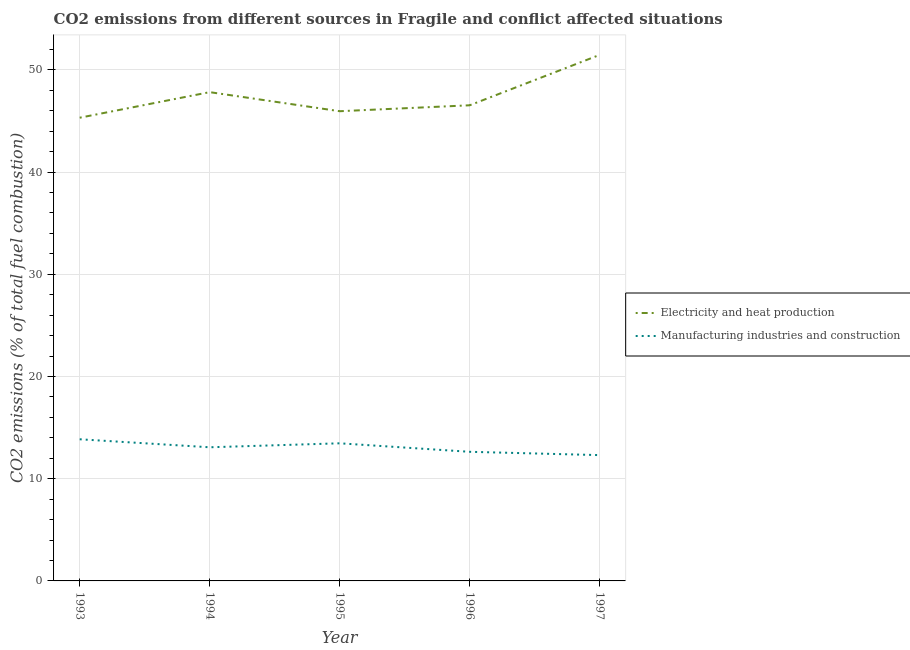Is the number of lines equal to the number of legend labels?
Ensure brevity in your answer.  Yes. What is the co2 emissions due to electricity and heat production in 1993?
Provide a short and direct response. 45.32. Across all years, what is the maximum co2 emissions due to electricity and heat production?
Your response must be concise. 51.46. Across all years, what is the minimum co2 emissions due to manufacturing industries?
Make the answer very short. 12.31. In which year was the co2 emissions due to electricity and heat production maximum?
Keep it short and to the point. 1997. What is the total co2 emissions due to manufacturing industries in the graph?
Your answer should be compact. 65.34. What is the difference between the co2 emissions due to electricity and heat production in 1993 and that in 1994?
Offer a terse response. -2.5. What is the difference between the co2 emissions due to electricity and heat production in 1993 and the co2 emissions due to manufacturing industries in 1994?
Ensure brevity in your answer.  32.24. What is the average co2 emissions due to manufacturing industries per year?
Make the answer very short. 13.07. In the year 1997, what is the difference between the co2 emissions due to electricity and heat production and co2 emissions due to manufacturing industries?
Ensure brevity in your answer.  39.16. What is the ratio of the co2 emissions due to electricity and heat production in 1993 to that in 1996?
Give a very brief answer. 0.97. Is the co2 emissions due to manufacturing industries in 1993 less than that in 1994?
Offer a very short reply. No. What is the difference between the highest and the second highest co2 emissions due to manufacturing industries?
Your answer should be compact. 0.39. What is the difference between the highest and the lowest co2 emissions due to electricity and heat production?
Give a very brief answer. 6.15. Is the co2 emissions due to electricity and heat production strictly less than the co2 emissions due to manufacturing industries over the years?
Make the answer very short. No. How many lines are there?
Keep it short and to the point. 2. How many years are there in the graph?
Keep it short and to the point. 5. What is the difference between two consecutive major ticks on the Y-axis?
Keep it short and to the point. 10. Does the graph contain grids?
Provide a succinct answer. Yes. How many legend labels are there?
Your answer should be compact. 2. How are the legend labels stacked?
Ensure brevity in your answer.  Vertical. What is the title of the graph?
Ensure brevity in your answer.  CO2 emissions from different sources in Fragile and conflict affected situations. What is the label or title of the X-axis?
Your response must be concise. Year. What is the label or title of the Y-axis?
Ensure brevity in your answer.  CO2 emissions (% of total fuel combustion). What is the CO2 emissions (% of total fuel combustion) of Electricity and heat production in 1993?
Offer a terse response. 45.32. What is the CO2 emissions (% of total fuel combustion) in Manufacturing industries and construction in 1993?
Offer a terse response. 13.86. What is the CO2 emissions (% of total fuel combustion) of Electricity and heat production in 1994?
Ensure brevity in your answer.  47.82. What is the CO2 emissions (% of total fuel combustion) in Manufacturing industries and construction in 1994?
Provide a succinct answer. 13.07. What is the CO2 emissions (% of total fuel combustion) in Electricity and heat production in 1995?
Provide a short and direct response. 45.95. What is the CO2 emissions (% of total fuel combustion) of Manufacturing industries and construction in 1995?
Keep it short and to the point. 13.46. What is the CO2 emissions (% of total fuel combustion) in Electricity and heat production in 1996?
Your response must be concise. 46.53. What is the CO2 emissions (% of total fuel combustion) of Manufacturing industries and construction in 1996?
Keep it short and to the point. 12.63. What is the CO2 emissions (% of total fuel combustion) of Electricity and heat production in 1997?
Ensure brevity in your answer.  51.46. What is the CO2 emissions (% of total fuel combustion) in Manufacturing industries and construction in 1997?
Make the answer very short. 12.31. Across all years, what is the maximum CO2 emissions (% of total fuel combustion) in Electricity and heat production?
Your answer should be very brief. 51.46. Across all years, what is the maximum CO2 emissions (% of total fuel combustion) of Manufacturing industries and construction?
Ensure brevity in your answer.  13.86. Across all years, what is the minimum CO2 emissions (% of total fuel combustion) of Electricity and heat production?
Your answer should be very brief. 45.32. Across all years, what is the minimum CO2 emissions (% of total fuel combustion) in Manufacturing industries and construction?
Offer a terse response. 12.31. What is the total CO2 emissions (% of total fuel combustion) of Electricity and heat production in the graph?
Give a very brief answer. 237.08. What is the total CO2 emissions (% of total fuel combustion) of Manufacturing industries and construction in the graph?
Offer a very short reply. 65.34. What is the difference between the CO2 emissions (% of total fuel combustion) of Electricity and heat production in 1993 and that in 1994?
Your answer should be very brief. -2.5. What is the difference between the CO2 emissions (% of total fuel combustion) of Manufacturing industries and construction in 1993 and that in 1994?
Provide a short and direct response. 0.78. What is the difference between the CO2 emissions (% of total fuel combustion) in Electricity and heat production in 1993 and that in 1995?
Your answer should be very brief. -0.64. What is the difference between the CO2 emissions (% of total fuel combustion) in Manufacturing industries and construction in 1993 and that in 1995?
Your response must be concise. 0.39. What is the difference between the CO2 emissions (% of total fuel combustion) of Electricity and heat production in 1993 and that in 1996?
Give a very brief answer. -1.22. What is the difference between the CO2 emissions (% of total fuel combustion) in Manufacturing industries and construction in 1993 and that in 1996?
Provide a short and direct response. 1.23. What is the difference between the CO2 emissions (% of total fuel combustion) in Electricity and heat production in 1993 and that in 1997?
Provide a succinct answer. -6.15. What is the difference between the CO2 emissions (% of total fuel combustion) in Manufacturing industries and construction in 1993 and that in 1997?
Your answer should be very brief. 1.55. What is the difference between the CO2 emissions (% of total fuel combustion) of Electricity and heat production in 1994 and that in 1995?
Make the answer very short. 1.87. What is the difference between the CO2 emissions (% of total fuel combustion) in Manufacturing industries and construction in 1994 and that in 1995?
Your answer should be very brief. -0.39. What is the difference between the CO2 emissions (% of total fuel combustion) of Electricity and heat production in 1994 and that in 1996?
Provide a succinct answer. 1.29. What is the difference between the CO2 emissions (% of total fuel combustion) of Manufacturing industries and construction in 1994 and that in 1996?
Provide a succinct answer. 0.44. What is the difference between the CO2 emissions (% of total fuel combustion) of Electricity and heat production in 1994 and that in 1997?
Keep it short and to the point. -3.65. What is the difference between the CO2 emissions (% of total fuel combustion) of Manufacturing industries and construction in 1994 and that in 1997?
Your response must be concise. 0.77. What is the difference between the CO2 emissions (% of total fuel combustion) of Electricity and heat production in 1995 and that in 1996?
Offer a terse response. -0.58. What is the difference between the CO2 emissions (% of total fuel combustion) in Manufacturing industries and construction in 1995 and that in 1996?
Offer a terse response. 0.83. What is the difference between the CO2 emissions (% of total fuel combustion) in Electricity and heat production in 1995 and that in 1997?
Offer a very short reply. -5.51. What is the difference between the CO2 emissions (% of total fuel combustion) of Manufacturing industries and construction in 1995 and that in 1997?
Ensure brevity in your answer.  1.16. What is the difference between the CO2 emissions (% of total fuel combustion) of Electricity and heat production in 1996 and that in 1997?
Offer a terse response. -4.93. What is the difference between the CO2 emissions (% of total fuel combustion) in Manufacturing industries and construction in 1996 and that in 1997?
Offer a very short reply. 0.32. What is the difference between the CO2 emissions (% of total fuel combustion) in Electricity and heat production in 1993 and the CO2 emissions (% of total fuel combustion) in Manufacturing industries and construction in 1994?
Give a very brief answer. 32.24. What is the difference between the CO2 emissions (% of total fuel combustion) of Electricity and heat production in 1993 and the CO2 emissions (% of total fuel combustion) of Manufacturing industries and construction in 1995?
Your answer should be very brief. 31.85. What is the difference between the CO2 emissions (% of total fuel combustion) in Electricity and heat production in 1993 and the CO2 emissions (% of total fuel combustion) in Manufacturing industries and construction in 1996?
Your answer should be very brief. 32.68. What is the difference between the CO2 emissions (% of total fuel combustion) of Electricity and heat production in 1993 and the CO2 emissions (% of total fuel combustion) of Manufacturing industries and construction in 1997?
Provide a short and direct response. 33.01. What is the difference between the CO2 emissions (% of total fuel combustion) of Electricity and heat production in 1994 and the CO2 emissions (% of total fuel combustion) of Manufacturing industries and construction in 1995?
Keep it short and to the point. 34.35. What is the difference between the CO2 emissions (% of total fuel combustion) of Electricity and heat production in 1994 and the CO2 emissions (% of total fuel combustion) of Manufacturing industries and construction in 1996?
Your answer should be very brief. 35.19. What is the difference between the CO2 emissions (% of total fuel combustion) of Electricity and heat production in 1994 and the CO2 emissions (% of total fuel combustion) of Manufacturing industries and construction in 1997?
Your answer should be very brief. 35.51. What is the difference between the CO2 emissions (% of total fuel combustion) in Electricity and heat production in 1995 and the CO2 emissions (% of total fuel combustion) in Manufacturing industries and construction in 1996?
Your response must be concise. 33.32. What is the difference between the CO2 emissions (% of total fuel combustion) of Electricity and heat production in 1995 and the CO2 emissions (% of total fuel combustion) of Manufacturing industries and construction in 1997?
Your answer should be very brief. 33.64. What is the difference between the CO2 emissions (% of total fuel combustion) in Electricity and heat production in 1996 and the CO2 emissions (% of total fuel combustion) in Manufacturing industries and construction in 1997?
Your response must be concise. 34.22. What is the average CO2 emissions (% of total fuel combustion) in Electricity and heat production per year?
Your answer should be compact. 47.42. What is the average CO2 emissions (% of total fuel combustion) in Manufacturing industries and construction per year?
Your response must be concise. 13.07. In the year 1993, what is the difference between the CO2 emissions (% of total fuel combustion) in Electricity and heat production and CO2 emissions (% of total fuel combustion) in Manufacturing industries and construction?
Your answer should be compact. 31.46. In the year 1994, what is the difference between the CO2 emissions (% of total fuel combustion) of Electricity and heat production and CO2 emissions (% of total fuel combustion) of Manufacturing industries and construction?
Keep it short and to the point. 34.74. In the year 1995, what is the difference between the CO2 emissions (% of total fuel combustion) in Electricity and heat production and CO2 emissions (% of total fuel combustion) in Manufacturing industries and construction?
Provide a short and direct response. 32.49. In the year 1996, what is the difference between the CO2 emissions (% of total fuel combustion) of Electricity and heat production and CO2 emissions (% of total fuel combustion) of Manufacturing industries and construction?
Provide a succinct answer. 33.9. In the year 1997, what is the difference between the CO2 emissions (% of total fuel combustion) in Electricity and heat production and CO2 emissions (% of total fuel combustion) in Manufacturing industries and construction?
Offer a terse response. 39.16. What is the ratio of the CO2 emissions (% of total fuel combustion) in Electricity and heat production in 1993 to that in 1994?
Provide a short and direct response. 0.95. What is the ratio of the CO2 emissions (% of total fuel combustion) of Manufacturing industries and construction in 1993 to that in 1994?
Your answer should be compact. 1.06. What is the ratio of the CO2 emissions (% of total fuel combustion) in Electricity and heat production in 1993 to that in 1995?
Your answer should be compact. 0.99. What is the ratio of the CO2 emissions (% of total fuel combustion) in Manufacturing industries and construction in 1993 to that in 1995?
Provide a short and direct response. 1.03. What is the ratio of the CO2 emissions (% of total fuel combustion) of Electricity and heat production in 1993 to that in 1996?
Provide a short and direct response. 0.97. What is the ratio of the CO2 emissions (% of total fuel combustion) of Manufacturing industries and construction in 1993 to that in 1996?
Your answer should be very brief. 1.1. What is the ratio of the CO2 emissions (% of total fuel combustion) in Electricity and heat production in 1993 to that in 1997?
Your answer should be compact. 0.88. What is the ratio of the CO2 emissions (% of total fuel combustion) of Manufacturing industries and construction in 1993 to that in 1997?
Offer a very short reply. 1.13. What is the ratio of the CO2 emissions (% of total fuel combustion) in Electricity and heat production in 1994 to that in 1995?
Provide a short and direct response. 1.04. What is the ratio of the CO2 emissions (% of total fuel combustion) in Manufacturing industries and construction in 1994 to that in 1995?
Your answer should be very brief. 0.97. What is the ratio of the CO2 emissions (% of total fuel combustion) in Electricity and heat production in 1994 to that in 1996?
Your answer should be compact. 1.03. What is the ratio of the CO2 emissions (% of total fuel combustion) in Manufacturing industries and construction in 1994 to that in 1996?
Offer a very short reply. 1.03. What is the ratio of the CO2 emissions (% of total fuel combustion) in Electricity and heat production in 1994 to that in 1997?
Offer a terse response. 0.93. What is the ratio of the CO2 emissions (% of total fuel combustion) of Manufacturing industries and construction in 1994 to that in 1997?
Offer a terse response. 1.06. What is the ratio of the CO2 emissions (% of total fuel combustion) of Electricity and heat production in 1995 to that in 1996?
Ensure brevity in your answer.  0.99. What is the ratio of the CO2 emissions (% of total fuel combustion) of Manufacturing industries and construction in 1995 to that in 1996?
Offer a terse response. 1.07. What is the ratio of the CO2 emissions (% of total fuel combustion) in Electricity and heat production in 1995 to that in 1997?
Ensure brevity in your answer.  0.89. What is the ratio of the CO2 emissions (% of total fuel combustion) in Manufacturing industries and construction in 1995 to that in 1997?
Offer a very short reply. 1.09. What is the ratio of the CO2 emissions (% of total fuel combustion) of Electricity and heat production in 1996 to that in 1997?
Ensure brevity in your answer.  0.9. What is the ratio of the CO2 emissions (% of total fuel combustion) of Manufacturing industries and construction in 1996 to that in 1997?
Make the answer very short. 1.03. What is the difference between the highest and the second highest CO2 emissions (% of total fuel combustion) of Electricity and heat production?
Ensure brevity in your answer.  3.65. What is the difference between the highest and the second highest CO2 emissions (% of total fuel combustion) in Manufacturing industries and construction?
Your answer should be compact. 0.39. What is the difference between the highest and the lowest CO2 emissions (% of total fuel combustion) in Electricity and heat production?
Provide a short and direct response. 6.15. What is the difference between the highest and the lowest CO2 emissions (% of total fuel combustion) in Manufacturing industries and construction?
Ensure brevity in your answer.  1.55. 